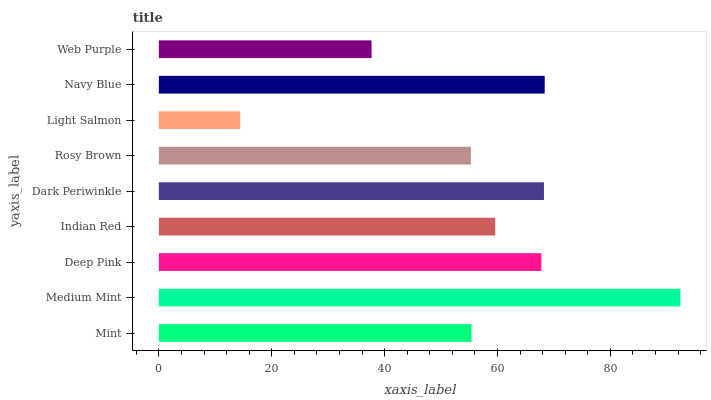Is Light Salmon the minimum?
Answer yes or no. Yes. Is Medium Mint the maximum?
Answer yes or no. Yes. Is Deep Pink the minimum?
Answer yes or no. No. Is Deep Pink the maximum?
Answer yes or no. No. Is Medium Mint greater than Deep Pink?
Answer yes or no. Yes. Is Deep Pink less than Medium Mint?
Answer yes or no. Yes. Is Deep Pink greater than Medium Mint?
Answer yes or no. No. Is Medium Mint less than Deep Pink?
Answer yes or no. No. Is Indian Red the high median?
Answer yes or no. Yes. Is Indian Red the low median?
Answer yes or no. Yes. Is Light Salmon the high median?
Answer yes or no. No. Is Dark Periwinkle the low median?
Answer yes or no. No. 